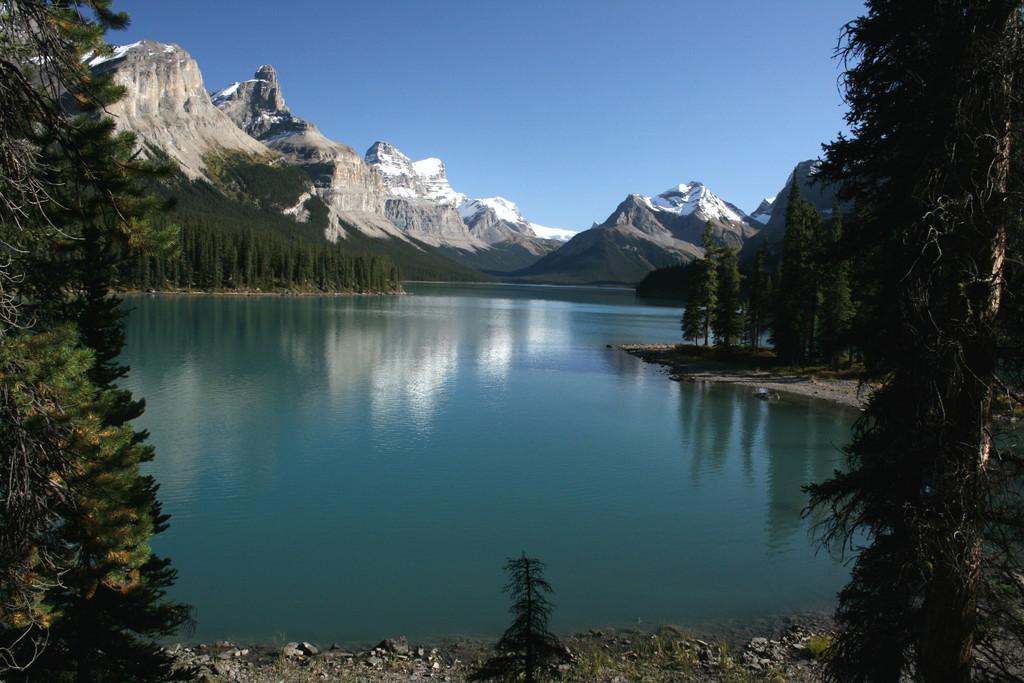Please provide a concise description of this image. On the left side, there is a tree on the ground. On the right side, there is a tree on the ground. In between them, there is a small plant on the ground. In the background, there is water. On both sides of this water, there are trees on the ground, there are mountains on which, there is snow and there is blue sky. 